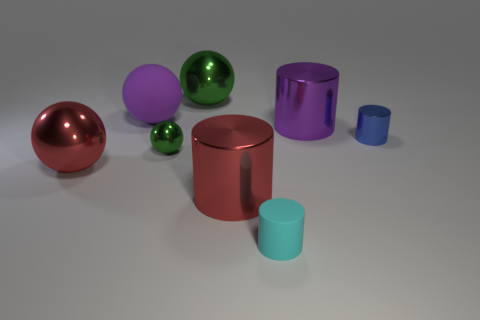Subtract 1 cylinders. How many cylinders are left? 3 Subtract all brown cylinders. Subtract all cyan balls. How many cylinders are left? 4 Add 2 blue cylinders. How many objects exist? 10 Add 5 tiny shiny objects. How many tiny shiny objects exist? 7 Subtract 1 red cylinders. How many objects are left? 7 Subtract all blue metal cylinders. Subtract all big purple spheres. How many objects are left? 6 Add 7 blue shiny objects. How many blue shiny objects are left? 8 